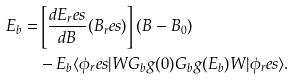<formula> <loc_0><loc_0><loc_500><loc_500>E _ { b } = & \left [ \frac { d E _ { r } e s } { d B } ( B _ { r } e s ) \right ] ( B - B _ { 0 } ) \\ & - E _ { b } \langle \phi _ { r } e s | W G _ { b } g ( 0 ) G _ { b } g ( E _ { b } ) W | \phi _ { r } e s \rangle .</formula> 